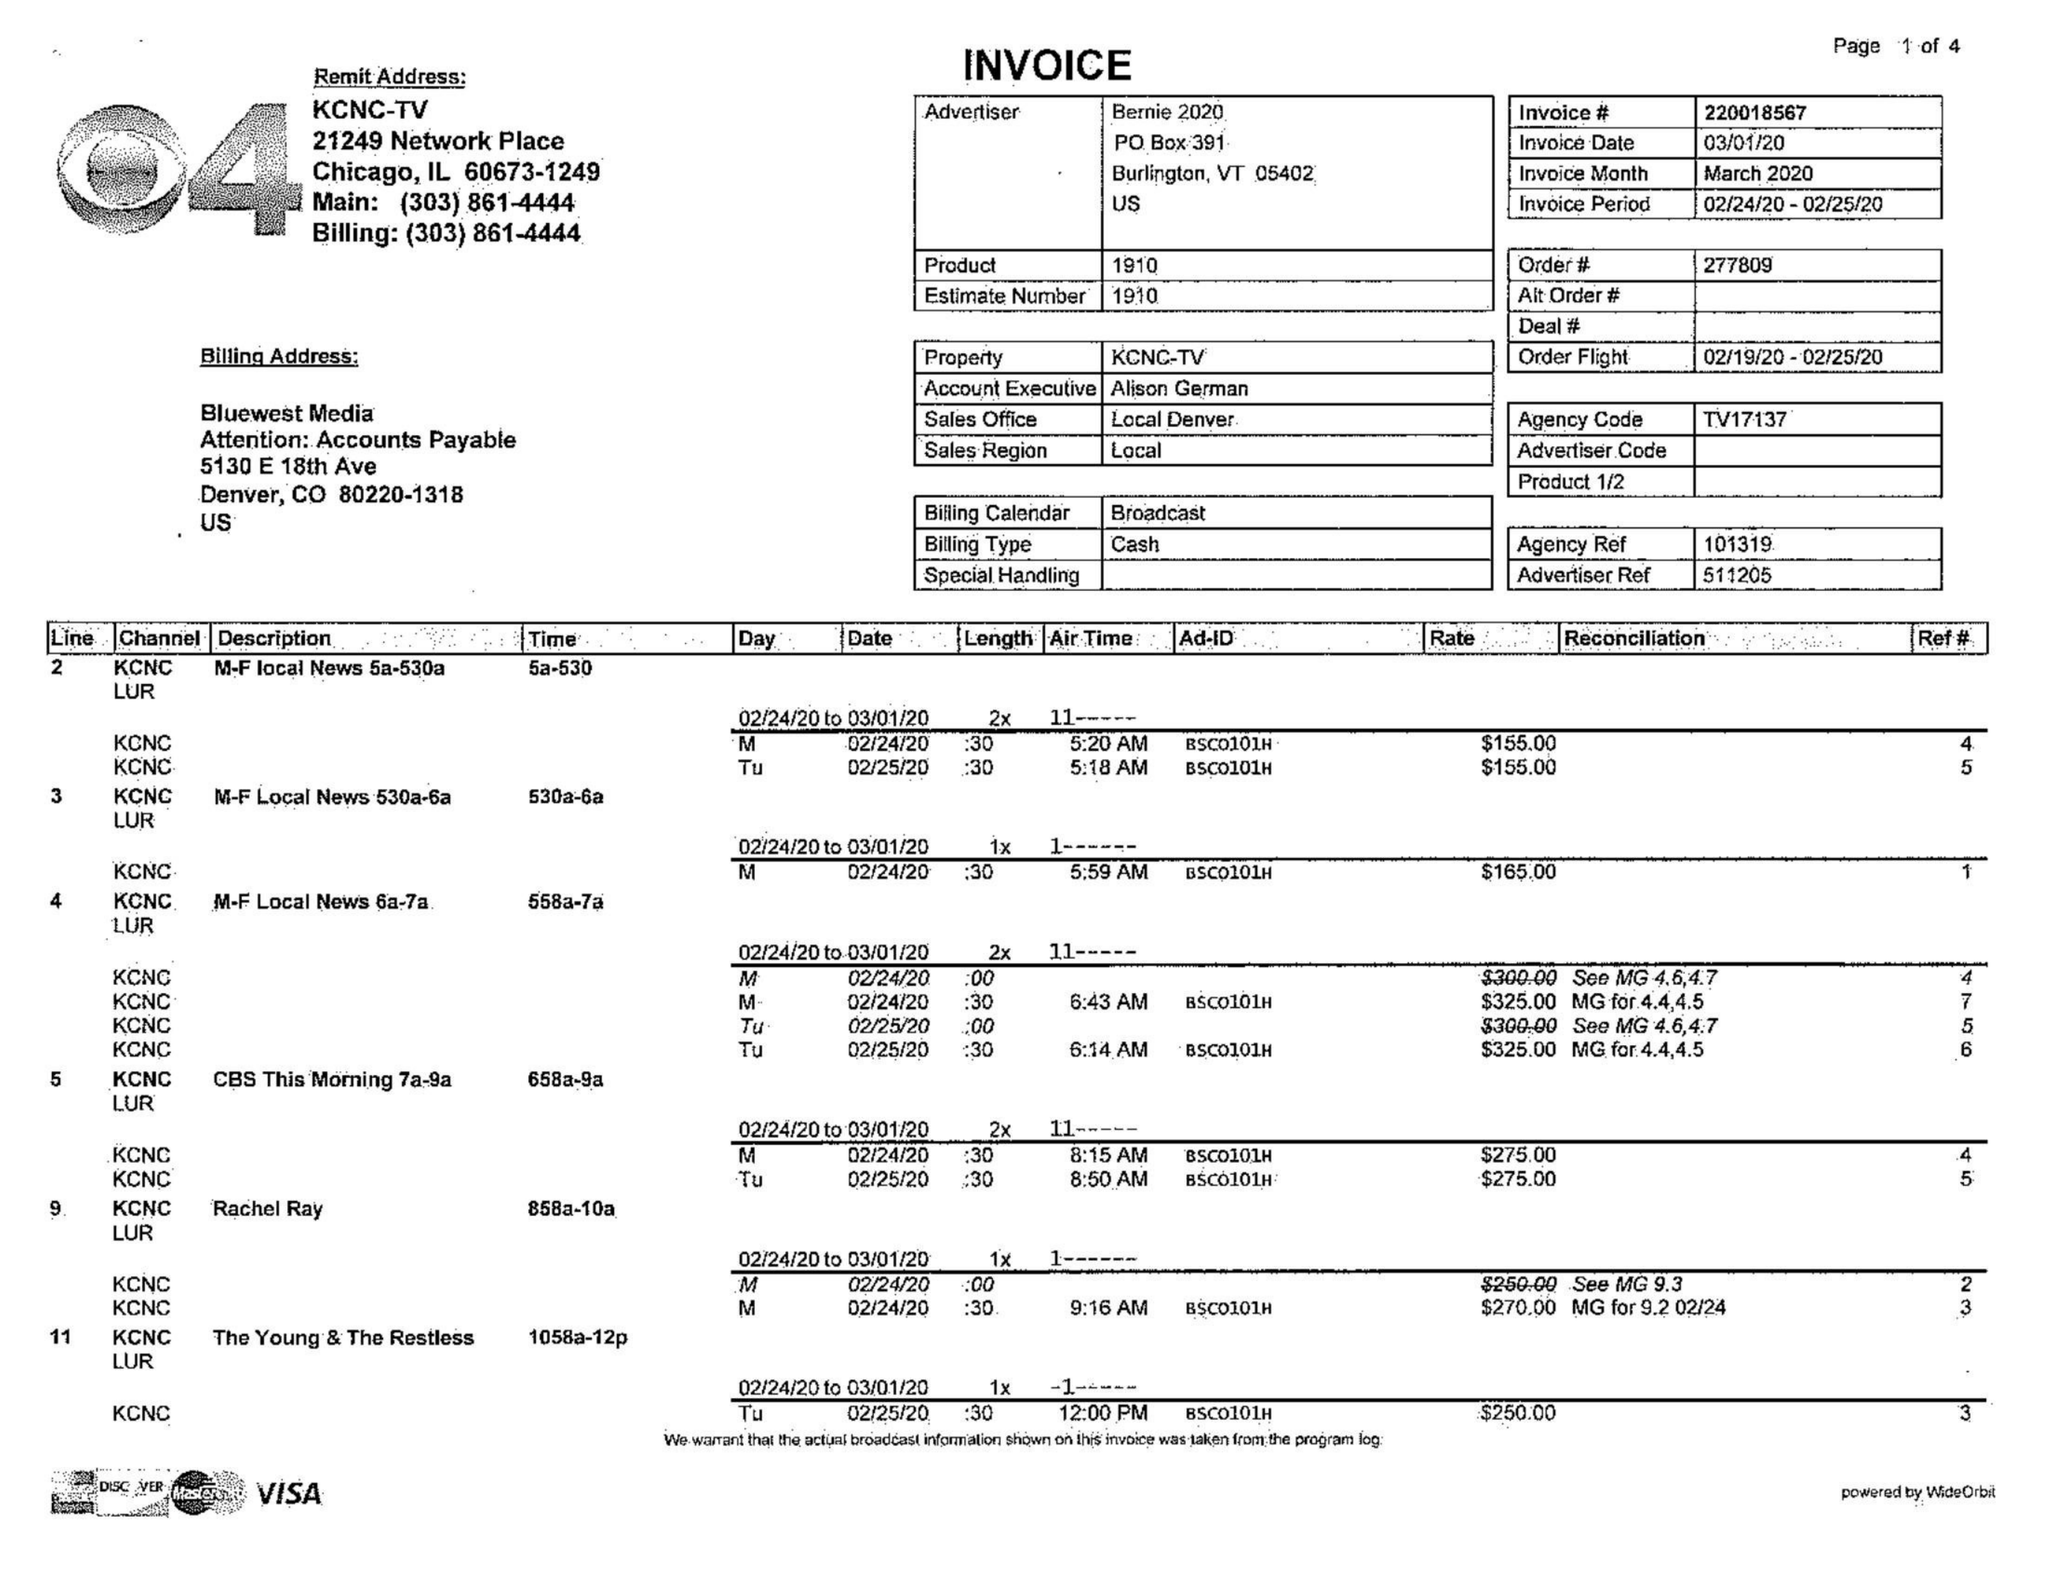What is the value for the flight_to?
Answer the question using a single word or phrase. 02/25/20 